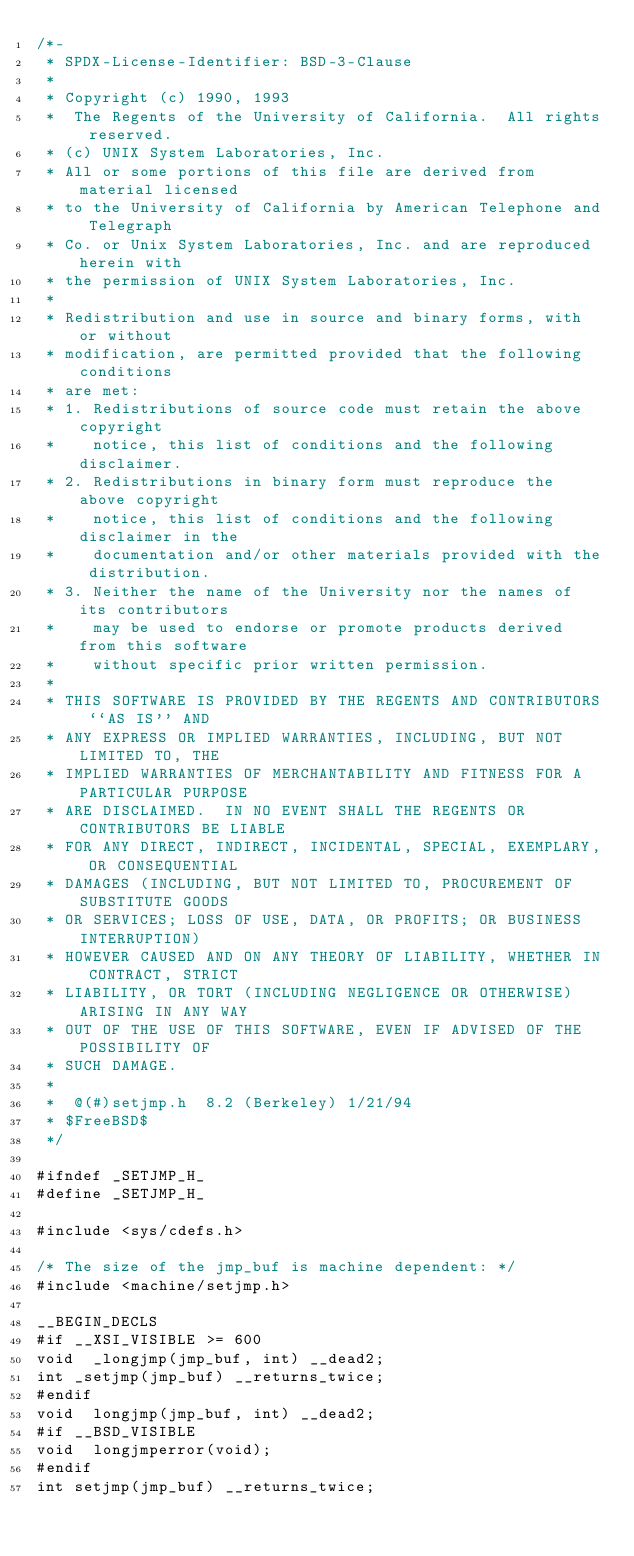<code> <loc_0><loc_0><loc_500><loc_500><_C_>/*-
 * SPDX-License-Identifier: BSD-3-Clause
 *
 * Copyright (c) 1990, 1993
 *	The Regents of the University of California.  All rights reserved.
 * (c) UNIX System Laboratories, Inc.
 * All or some portions of this file are derived from material licensed
 * to the University of California by American Telephone and Telegraph
 * Co. or Unix System Laboratories, Inc. and are reproduced herein with
 * the permission of UNIX System Laboratories, Inc.
 *
 * Redistribution and use in source and binary forms, with or without
 * modification, are permitted provided that the following conditions
 * are met:
 * 1. Redistributions of source code must retain the above copyright
 *    notice, this list of conditions and the following disclaimer.
 * 2. Redistributions in binary form must reproduce the above copyright
 *    notice, this list of conditions and the following disclaimer in the
 *    documentation and/or other materials provided with the distribution.
 * 3. Neither the name of the University nor the names of its contributors
 *    may be used to endorse or promote products derived from this software
 *    without specific prior written permission.
 *
 * THIS SOFTWARE IS PROVIDED BY THE REGENTS AND CONTRIBUTORS ``AS IS'' AND
 * ANY EXPRESS OR IMPLIED WARRANTIES, INCLUDING, BUT NOT LIMITED TO, THE
 * IMPLIED WARRANTIES OF MERCHANTABILITY AND FITNESS FOR A PARTICULAR PURPOSE
 * ARE DISCLAIMED.  IN NO EVENT SHALL THE REGENTS OR CONTRIBUTORS BE LIABLE
 * FOR ANY DIRECT, INDIRECT, INCIDENTAL, SPECIAL, EXEMPLARY, OR CONSEQUENTIAL
 * DAMAGES (INCLUDING, BUT NOT LIMITED TO, PROCUREMENT OF SUBSTITUTE GOODS
 * OR SERVICES; LOSS OF USE, DATA, OR PROFITS; OR BUSINESS INTERRUPTION)
 * HOWEVER CAUSED AND ON ANY THEORY OF LIABILITY, WHETHER IN CONTRACT, STRICT
 * LIABILITY, OR TORT (INCLUDING NEGLIGENCE OR OTHERWISE) ARISING IN ANY WAY
 * OUT OF THE USE OF THIS SOFTWARE, EVEN IF ADVISED OF THE POSSIBILITY OF
 * SUCH DAMAGE.
 *
 *	@(#)setjmp.h	8.2 (Berkeley) 1/21/94
 * $FreeBSD$
 */

#ifndef _SETJMP_H_
#define _SETJMP_H_

#include <sys/cdefs.h>

/* The size of the jmp_buf is machine dependent: */
#include <machine/setjmp.h>

__BEGIN_DECLS
#if __XSI_VISIBLE >= 600
void	_longjmp(jmp_buf, int) __dead2;
int	_setjmp(jmp_buf) __returns_twice;
#endif
void	longjmp(jmp_buf, int) __dead2;
#if __BSD_VISIBLE
void	longjmperror(void);
#endif
int	setjmp(jmp_buf) __returns_twice;</code> 